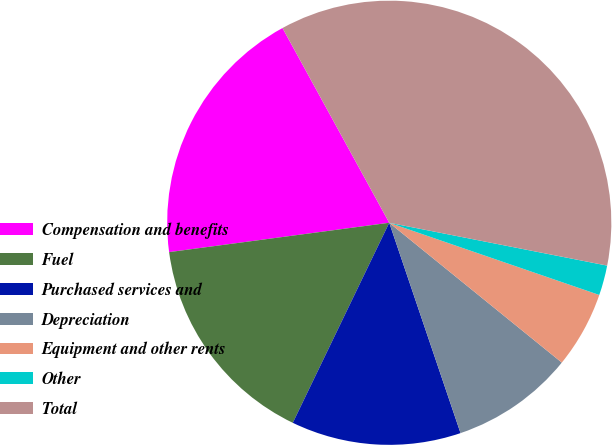<chart> <loc_0><loc_0><loc_500><loc_500><pie_chart><fcel>Compensation and benefits<fcel>Fuel<fcel>Purchased services and<fcel>Depreciation<fcel>Equipment and other rents<fcel>Other<fcel>Total<nl><fcel>19.13%<fcel>15.74%<fcel>12.35%<fcel>8.96%<fcel>5.57%<fcel>2.18%<fcel>36.07%<nl></chart> 